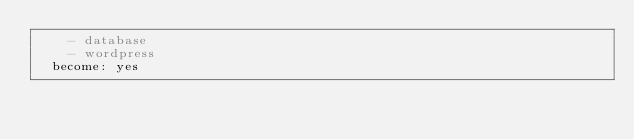Convert code to text. <code><loc_0><loc_0><loc_500><loc_500><_YAML_>    - database
    - wordpress
  become: yes
</code> 